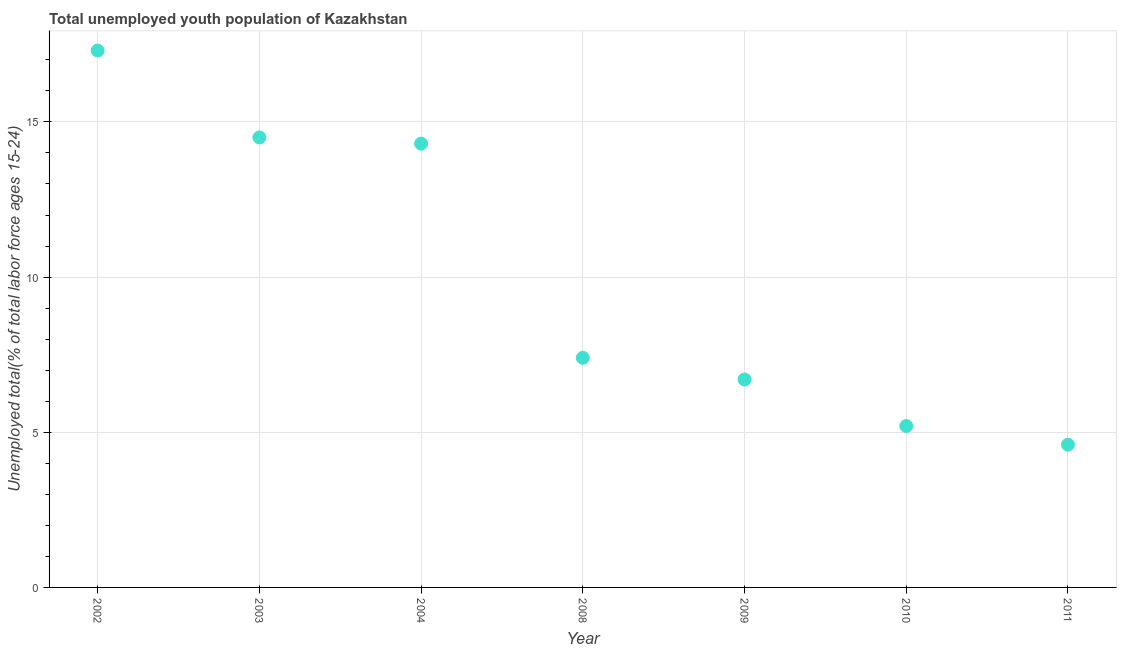What is the unemployed youth in 2011?
Give a very brief answer. 4.6. Across all years, what is the maximum unemployed youth?
Provide a succinct answer. 17.3. Across all years, what is the minimum unemployed youth?
Your answer should be compact. 4.6. What is the sum of the unemployed youth?
Give a very brief answer. 70. What is the difference between the unemployed youth in 2003 and 2009?
Keep it short and to the point. 7.8. What is the average unemployed youth per year?
Offer a very short reply. 10. What is the median unemployed youth?
Your answer should be very brief. 7.4. Do a majority of the years between 2009 and 2002 (inclusive) have unemployed youth greater than 11 %?
Keep it short and to the point. Yes. What is the ratio of the unemployed youth in 2002 to that in 2009?
Provide a succinct answer. 2.58. Is the unemployed youth in 2009 less than that in 2010?
Your answer should be very brief. No. Is the difference between the unemployed youth in 2002 and 2008 greater than the difference between any two years?
Provide a succinct answer. No. What is the difference between the highest and the second highest unemployed youth?
Make the answer very short. 2.8. Is the sum of the unemployed youth in 2003 and 2008 greater than the maximum unemployed youth across all years?
Offer a terse response. Yes. What is the difference between the highest and the lowest unemployed youth?
Your answer should be very brief. 12.7. In how many years, is the unemployed youth greater than the average unemployed youth taken over all years?
Give a very brief answer. 3. Does the unemployed youth monotonically increase over the years?
Give a very brief answer. No. How many dotlines are there?
Provide a short and direct response. 1. How many years are there in the graph?
Make the answer very short. 7. What is the difference between two consecutive major ticks on the Y-axis?
Your answer should be compact. 5. Does the graph contain any zero values?
Give a very brief answer. No. Does the graph contain grids?
Your answer should be compact. Yes. What is the title of the graph?
Keep it short and to the point. Total unemployed youth population of Kazakhstan. What is the label or title of the X-axis?
Ensure brevity in your answer.  Year. What is the label or title of the Y-axis?
Provide a short and direct response. Unemployed total(% of total labor force ages 15-24). What is the Unemployed total(% of total labor force ages 15-24) in 2002?
Provide a short and direct response. 17.3. What is the Unemployed total(% of total labor force ages 15-24) in 2003?
Your answer should be compact. 14.5. What is the Unemployed total(% of total labor force ages 15-24) in 2004?
Ensure brevity in your answer.  14.3. What is the Unemployed total(% of total labor force ages 15-24) in 2008?
Your response must be concise. 7.4. What is the Unemployed total(% of total labor force ages 15-24) in 2009?
Offer a very short reply. 6.7. What is the Unemployed total(% of total labor force ages 15-24) in 2010?
Offer a very short reply. 5.2. What is the Unemployed total(% of total labor force ages 15-24) in 2011?
Your answer should be very brief. 4.6. What is the difference between the Unemployed total(% of total labor force ages 15-24) in 2002 and 2003?
Provide a short and direct response. 2.8. What is the difference between the Unemployed total(% of total labor force ages 15-24) in 2002 and 2008?
Keep it short and to the point. 9.9. What is the difference between the Unemployed total(% of total labor force ages 15-24) in 2002 and 2009?
Offer a very short reply. 10.6. What is the difference between the Unemployed total(% of total labor force ages 15-24) in 2003 and 2008?
Offer a very short reply. 7.1. What is the difference between the Unemployed total(% of total labor force ages 15-24) in 2003 and 2010?
Your answer should be very brief. 9.3. What is the difference between the Unemployed total(% of total labor force ages 15-24) in 2003 and 2011?
Give a very brief answer. 9.9. What is the difference between the Unemployed total(% of total labor force ages 15-24) in 2004 and 2008?
Ensure brevity in your answer.  6.9. What is the difference between the Unemployed total(% of total labor force ages 15-24) in 2004 and 2009?
Make the answer very short. 7.6. What is the difference between the Unemployed total(% of total labor force ages 15-24) in 2004 and 2010?
Ensure brevity in your answer.  9.1. What is the difference between the Unemployed total(% of total labor force ages 15-24) in 2008 and 2009?
Your answer should be compact. 0.7. What is the difference between the Unemployed total(% of total labor force ages 15-24) in 2009 and 2010?
Your answer should be very brief. 1.5. What is the ratio of the Unemployed total(% of total labor force ages 15-24) in 2002 to that in 2003?
Give a very brief answer. 1.19. What is the ratio of the Unemployed total(% of total labor force ages 15-24) in 2002 to that in 2004?
Offer a very short reply. 1.21. What is the ratio of the Unemployed total(% of total labor force ages 15-24) in 2002 to that in 2008?
Offer a terse response. 2.34. What is the ratio of the Unemployed total(% of total labor force ages 15-24) in 2002 to that in 2009?
Your response must be concise. 2.58. What is the ratio of the Unemployed total(% of total labor force ages 15-24) in 2002 to that in 2010?
Ensure brevity in your answer.  3.33. What is the ratio of the Unemployed total(% of total labor force ages 15-24) in 2002 to that in 2011?
Your answer should be compact. 3.76. What is the ratio of the Unemployed total(% of total labor force ages 15-24) in 2003 to that in 2004?
Your response must be concise. 1.01. What is the ratio of the Unemployed total(% of total labor force ages 15-24) in 2003 to that in 2008?
Give a very brief answer. 1.96. What is the ratio of the Unemployed total(% of total labor force ages 15-24) in 2003 to that in 2009?
Give a very brief answer. 2.16. What is the ratio of the Unemployed total(% of total labor force ages 15-24) in 2003 to that in 2010?
Provide a succinct answer. 2.79. What is the ratio of the Unemployed total(% of total labor force ages 15-24) in 2003 to that in 2011?
Give a very brief answer. 3.15. What is the ratio of the Unemployed total(% of total labor force ages 15-24) in 2004 to that in 2008?
Give a very brief answer. 1.93. What is the ratio of the Unemployed total(% of total labor force ages 15-24) in 2004 to that in 2009?
Ensure brevity in your answer.  2.13. What is the ratio of the Unemployed total(% of total labor force ages 15-24) in 2004 to that in 2010?
Your answer should be compact. 2.75. What is the ratio of the Unemployed total(% of total labor force ages 15-24) in 2004 to that in 2011?
Keep it short and to the point. 3.11. What is the ratio of the Unemployed total(% of total labor force ages 15-24) in 2008 to that in 2009?
Provide a succinct answer. 1.1. What is the ratio of the Unemployed total(% of total labor force ages 15-24) in 2008 to that in 2010?
Keep it short and to the point. 1.42. What is the ratio of the Unemployed total(% of total labor force ages 15-24) in 2008 to that in 2011?
Offer a terse response. 1.61. What is the ratio of the Unemployed total(% of total labor force ages 15-24) in 2009 to that in 2010?
Your answer should be compact. 1.29. What is the ratio of the Unemployed total(% of total labor force ages 15-24) in 2009 to that in 2011?
Make the answer very short. 1.46. What is the ratio of the Unemployed total(% of total labor force ages 15-24) in 2010 to that in 2011?
Give a very brief answer. 1.13. 